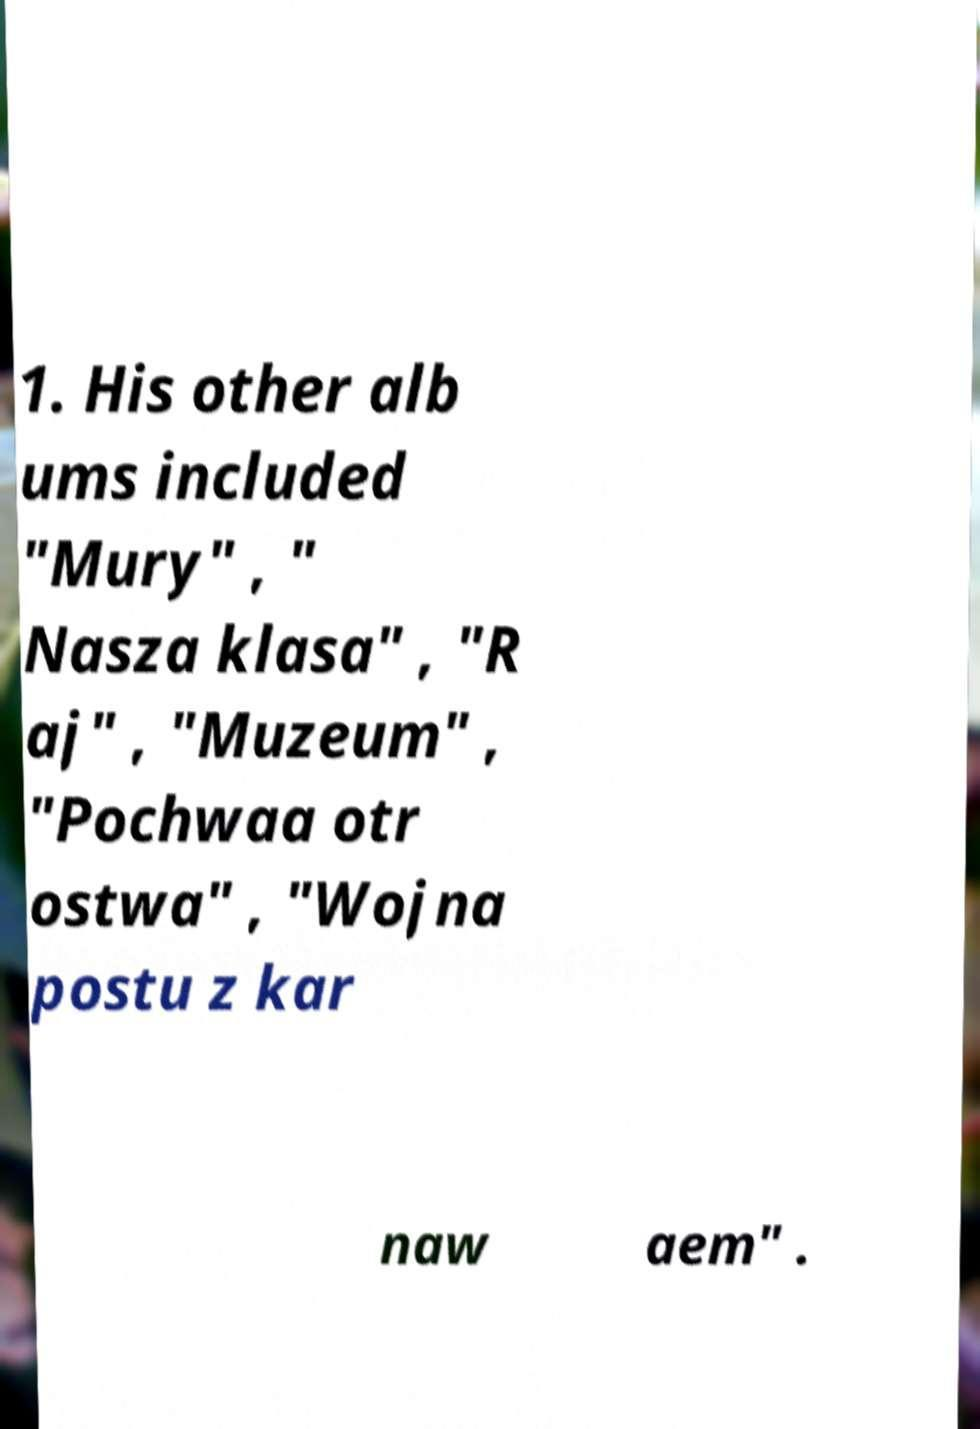Could you assist in decoding the text presented in this image and type it out clearly? 1. His other alb ums included "Mury" , " Nasza klasa" , "R aj" , "Muzeum" , "Pochwaa otr ostwa" , "Wojna postu z kar naw aem" . 